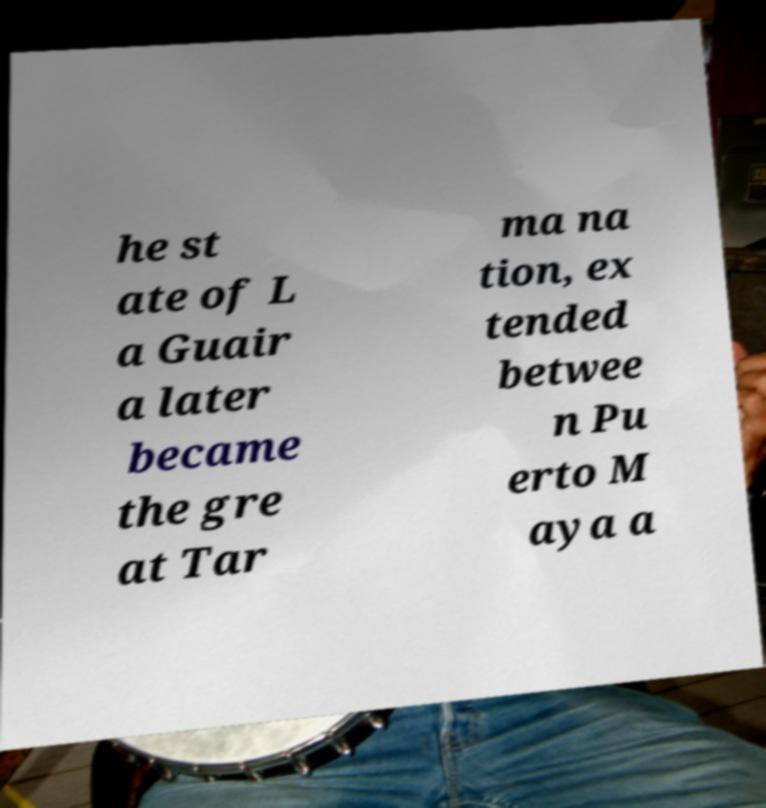Could you assist in decoding the text presented in this image and type it out clearly? he st ate of L a Guair a later became the gre at Tar ma na tion, ex tended betwee n Pu erto M aya a 